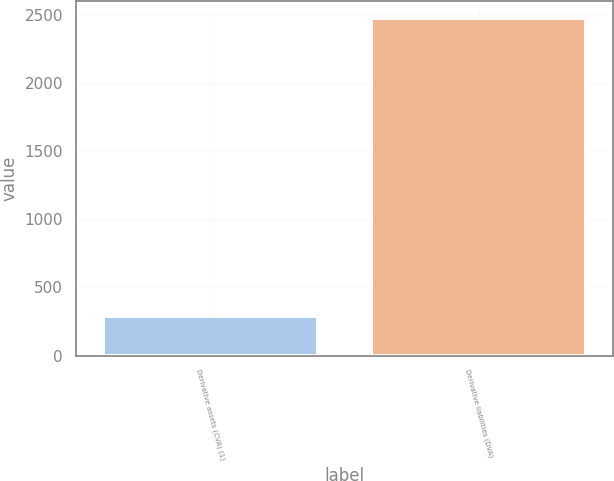<chart> <loc_0><loc_0><loc_500><loc_500><bar_chart><fcel>Derivative assets (CVA) (1)<fcel>Derivative liabilities (DVA)<nl><fcel>291<fcel>2477<nl></chart> 